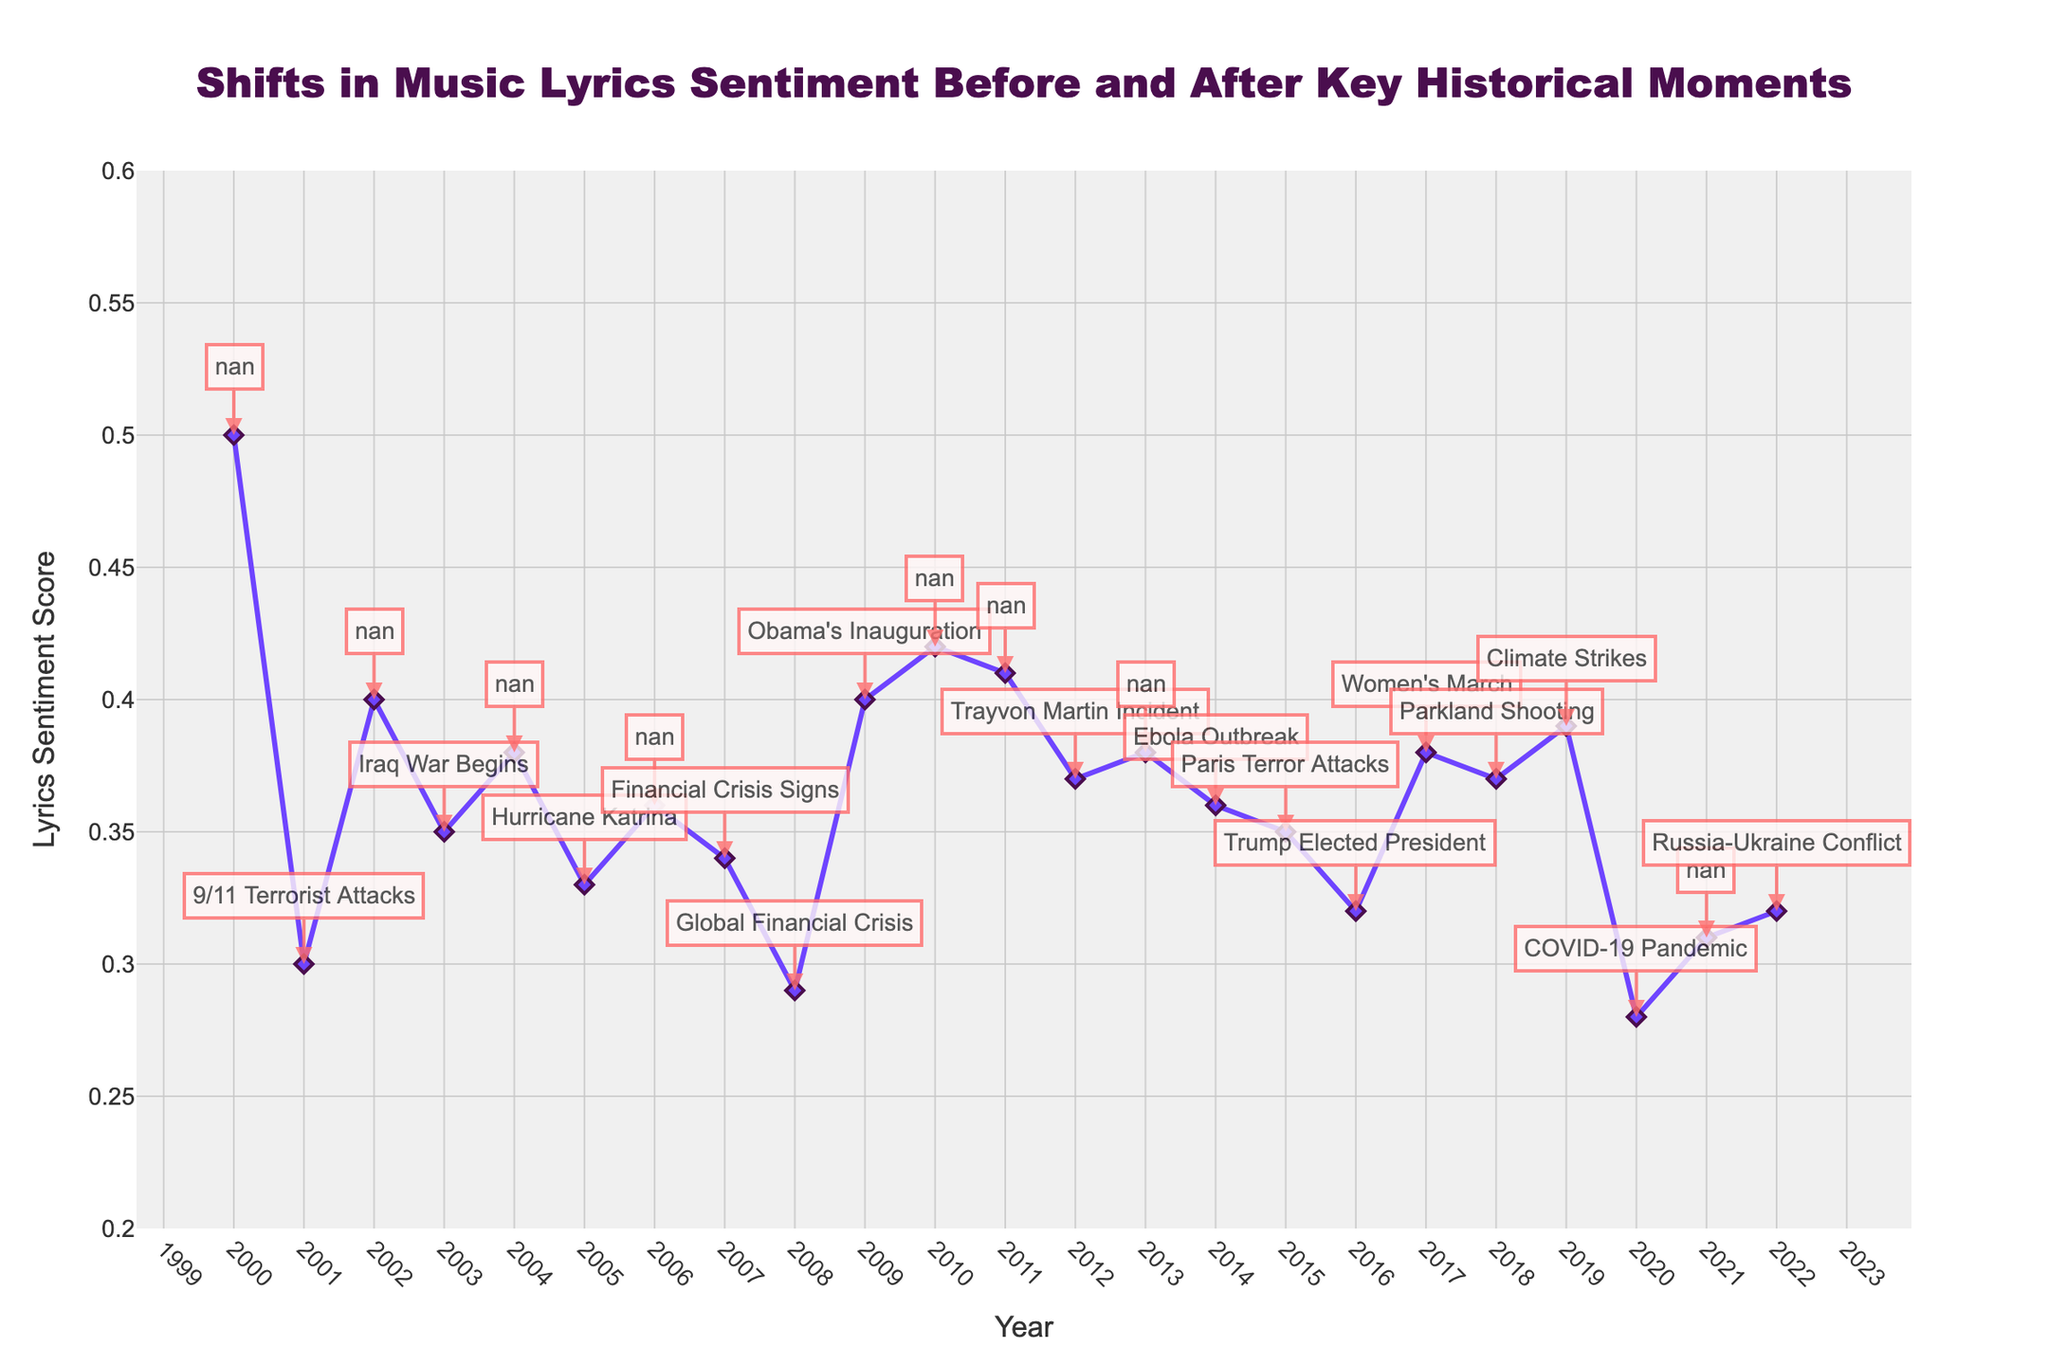What is the overall title of the plot? The title of the plot is at the top and reads "Shifts in Music Lyrics Sentiment Before and After Key Historical Moments."
Answer: Shifts in Music Lyrics Sentiment Before and After Key Historical Moments Which event corresponds to the lowest Lyrics Sentiment Score? The lowest point on the y-axis, which is around 0.28, is annotated with the event "COVID-19 Pandemic" in 2020.
Answer: COVID-19 Pandemic How did the Lyrics Sentiment Score change from 2000 to 2001? In 2000, the score is 0.5, and in 2001, it drops to 0.3. This is a decrease of 0.2.
Answer: Decreased by 0.2 Which year shows an increase in Lyrics Sentiment Score after "Obama’s Inauguration"? The score increases from 2008 (0.29) to 2009 (0.4), following Obama’s Inauguration.
Answer: 2009 Describe the general trend in Lyrics Sentiment Score from 2015 to 2017. The score in 2015 is 0.35, which stays relatively stable in 2016 at 0.32 and then increases in 2017 to 0.38.
Answer: Decrease first, then increase From 2001 to 2005, how many events are annotated and what is the general trend in the sentiment score? There are two events annotated: "9/11 Terrorist Attacks" in 2001 and "Iraq War Begins" in 2003. The sentiment score generally fluctuates slightly but remains relatively low, starting at 0.3 in 2001 and ending at 0.33 in 2005.
Answer: Two events, slight fluctuation What was the Lyrics Sentiment Score during the "Global Financial Crisis"? The annotation for the "Global Financial Crisis" in 2008 points to a sentiment score of 0.29.
Answer: 0.29 Between which two consecutive years did we observe the largest drop in Lyrics Sentiment Score? Comparing year-to-year changes, the largest drop occurs between 2019 (0.39) and 2020 (0.28), a difference of 0.11.
Answer: 2019 and 2020 What is the average Lyrics Sentiment Score from 2011 to 2015? The scores for 2011, 2012, 2013, 2014, and 2015 are 0.41, 0.37, 0.38, 0.36, and 0.35 respectively. Summing these up (0.41 + 0.37 + 0.38 + 0.36 + 0.35) equals 1.87. Dividing by 5 gives an average of 0.374.
Answer: 0.374 What is the highest Lyrics Sentiment Score observed and in which year did it occur? The highest score observed is 0.5 in the year 2000.
Answer: 0.5 in 2000 